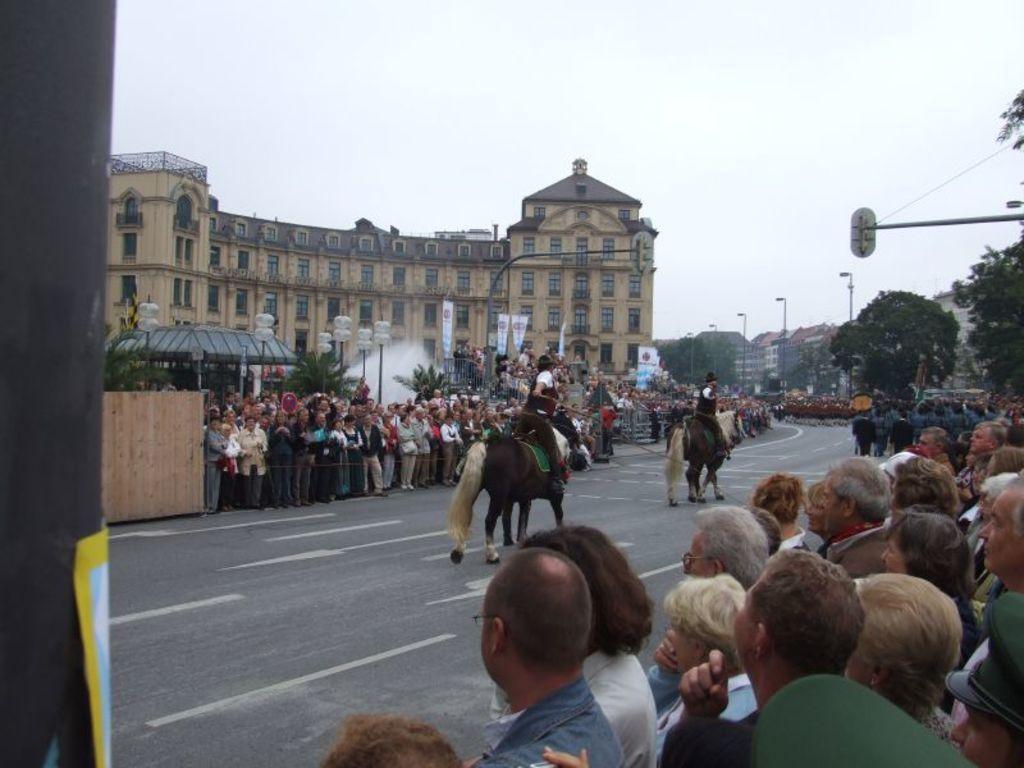Please provide a concise description of this image. In this image I can see group of people standing. I can see two people are sitting on the horse. They are in brown and white color. I can see buildings,windows,trees,light-poles,traffic-signals and trees. The sky is in white and blue color. 